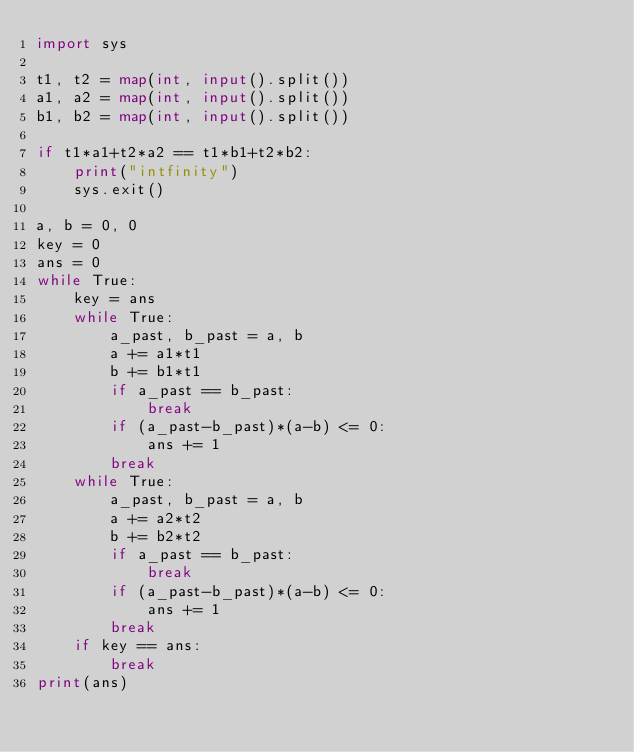Convert code to text. <code><loc_0><loc_0><loc_500><loc_500><_Python_>import sys

t1, t2 = map(int, input().split())
a1, a2 = map(int, input().split())
b1, b2 = map(int, input().split())

if t1*a1+t2*a2 == t1*b1+t2*b2:
    print("intfinity")
    sys.exit()

a, b = 0, 0
key = 0
ans = 0
while True:
    key = ans
    while True:
        a_past, b_past = a, b
        a += a1*t1
        b += b1*t1
        if a_past == b_past:
            break
        if (a_past-b_past)*(a-b) <= 0:
            ans += 1
        break
    while True:
        a_past, b_past = a, b
        a += a2*t2
        b += b2*t2
        if a_past == b_past:
            break
        if (a_past-b_past)*(a-b) <= 0:
            ans += 1
        break
    if key == ans:
        break
print(ans)</code> 